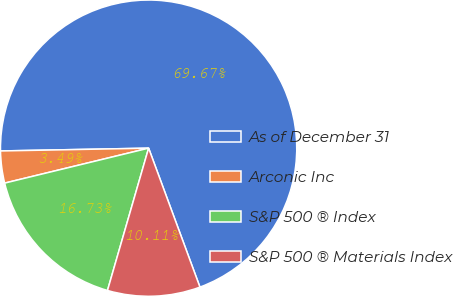Convert chart. <chart><loc_0><loc_0><loc_500><loc_500><pie_chart><fcel>As of December 31<fcel>Arconic Inc<fcel>S&P 500 ® Index<fcel>S&P 500 ® Materials Index<nl><fcel>69.67%<fcel>3.49%<fcel>16.73%<fcel>10.11%<nl></chart> 